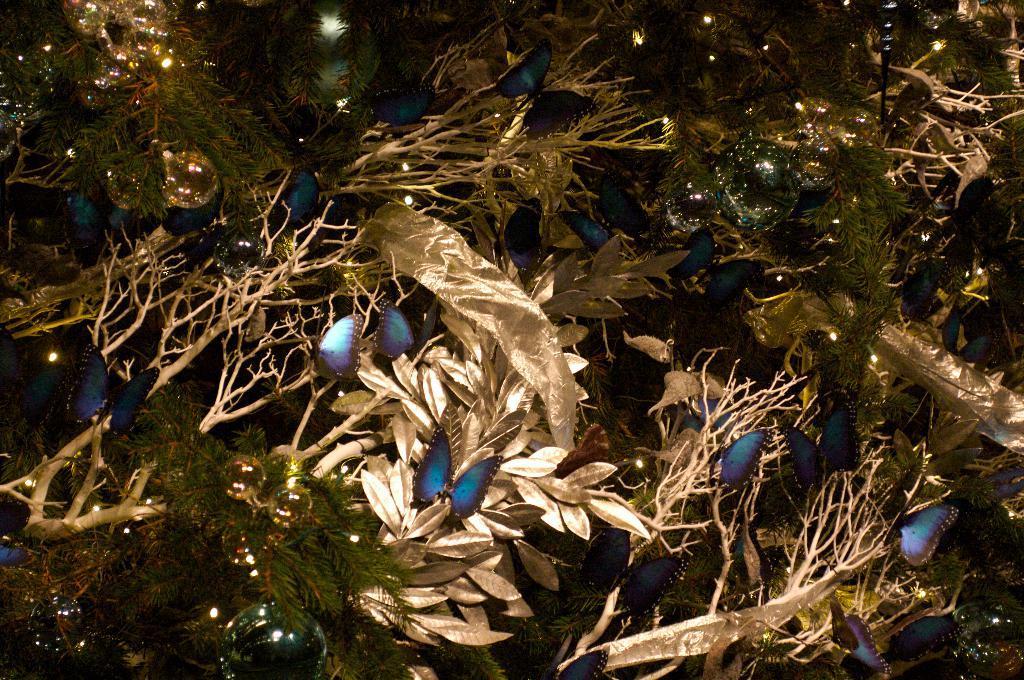How would you summarize this image in a sentence or two? In the picture I can see the leaves, butterflies and lights. 